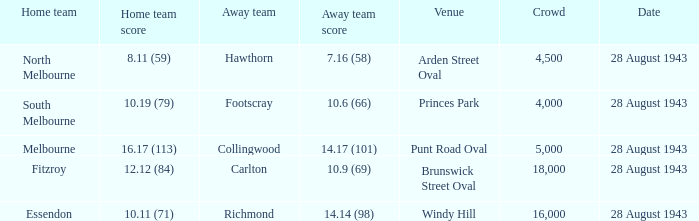What game showed a home team score of 8.11 (59)? 28 August 1943. 